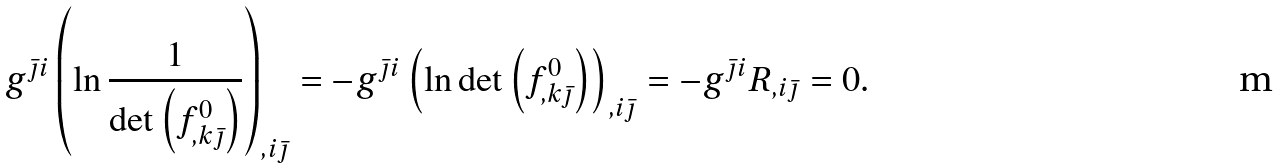<formula> <loc_0><loc_0><loc_500><loc_500>g ^ { \bar { \jmath } i } \left ( \ln \frac { 1 } { \det \left ( f ^ { 0 } _ { , k \bar { \jmath } } \right ) } \right ) _ { , i \bar { \jmath } } = - g ^ { \bar { \jmath } i } \left ( \ln \det \left ( f ^ { 0 } _ { , k \bar { \jmath } } \right ) \right ) _ { , i \bar { \jmath } } = - g ^ { \bar { \jmath } i } R _ { , i \bar { \jmath } } = 0 .</formula> 